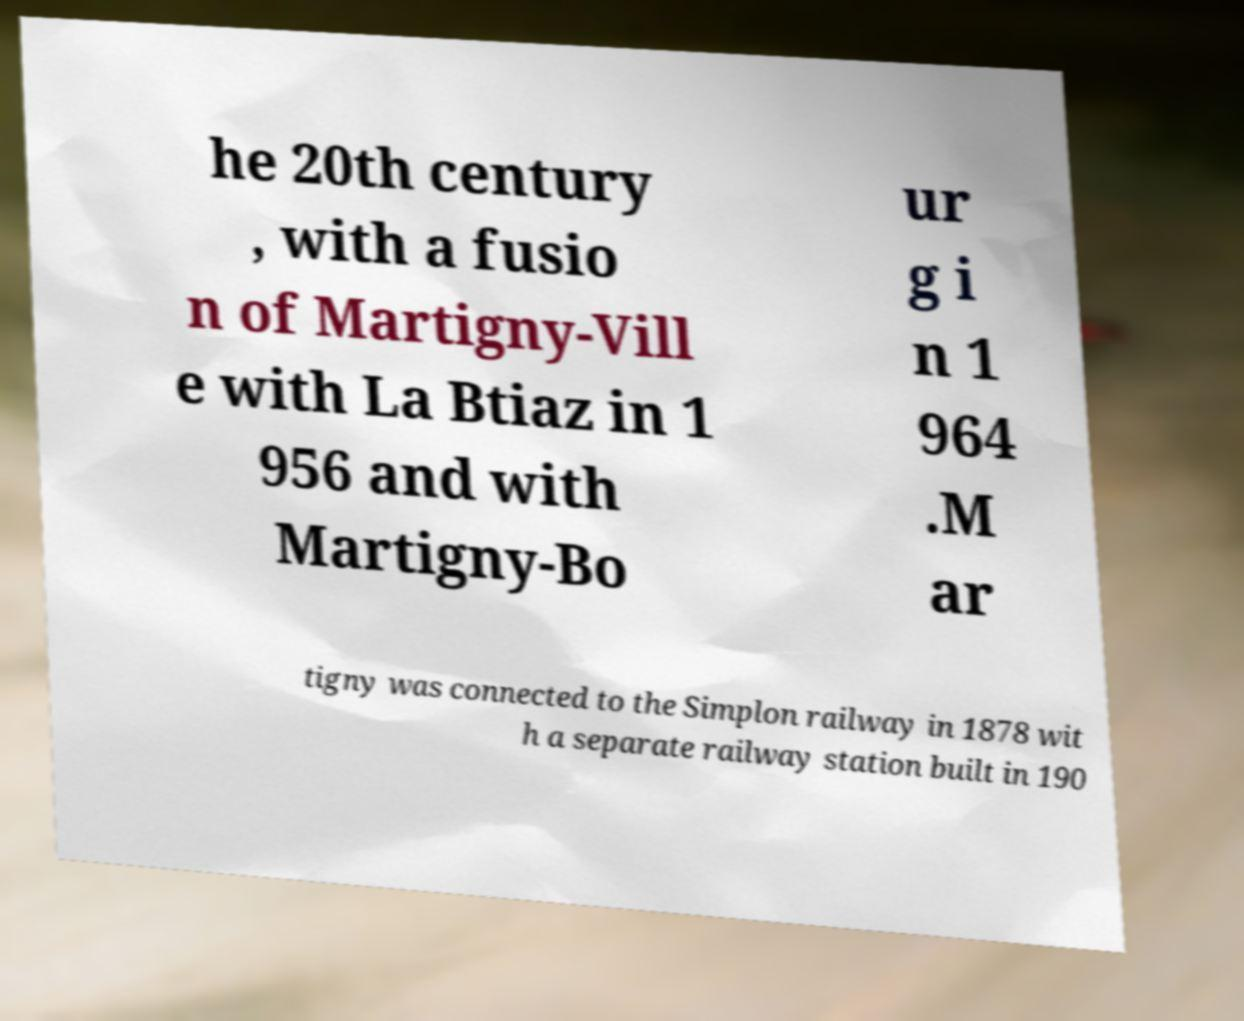Can you read and provide the text displayed in the image?This photo seems to have some interesting text. Can you extract and type it out for me? he 20th century , with a fusio n of Martigny-Vill e with La Btiaz in 1 956 and with Martigny-Bo ur g i n 1 964 .M ar tigny was connected to the Simplon railway in 1878 wit h a separate railway station built in 190 